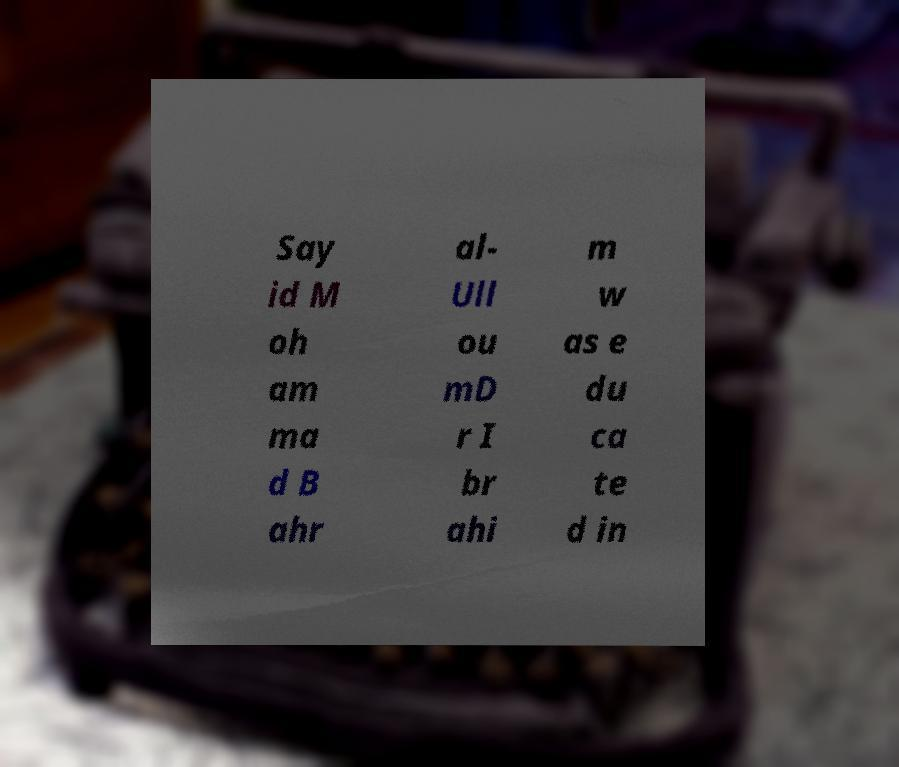Could you assist in decoding the text presented in this image and type it out clearly? Say id M oh am ma d B ahr al- Ull ou mD r I br ahi m w as e du ca te d in 